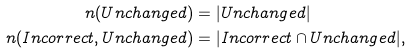Convert formula to latex. <formula><loc_0><loc_0><loc_500><loc_500>n ( U n c h a n g e d ) & = | U n c h a n g e d | \\ n ( I n c o r r e c t , U n c h a n g e d ) & = | I n c o r r e c t \cap U n c h a n g e d | ,</formula> 